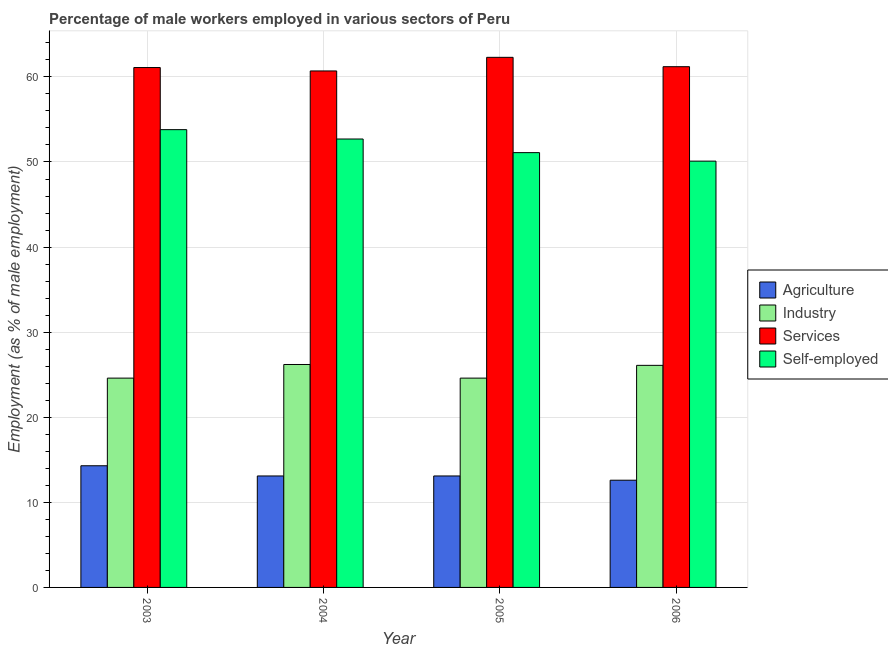How many groups of bars are there?
Provide a succinct answer. 4. Are the number of bars per tick equal to the number of legend labels?
Give a very brief answer. Yes. Are the number of bars on each tick of the X-axis equal?
Your answer should be very brief. Yes. What is the percentage of male workers in services in 2006?
Ensure brevity in your answer.  61.2. Across all years, what is the maximum percentage of male workers in industry?
Give a very brief answer. 26.2. Across all years, what is the minimum percentage of male workers in agriculture?
Your response must be concise. 12.6. In which year was the percentage of male workers in industry maximum?
Your answer should be very brief. 2004. In which year was the percentage of male workers in agriculture minimum?
Give a very brief answer. 2006. What is the total percentage of self employed male workers in the graph?
Your answer should be compact. 207.7. What is the average percentage of self employed male workers per year?
Offer a very short reply. 51.92. In the year 2005, what is the difference between the percentage of male workers in industry and percentage of male workers in agriculture?
Offer a terse response. 0. In how many years, is the percentage of male workers in industry greater than 14 %?
Provide a succinct answer. 4. What is the ratio of the percentage of male workers in services in 2003 to that in 2004?
Provide a succinct answer. 1.01. Is the percentage of male workers in agriculture in 2003 less than that in 2005?
Your response must be concise. No. What is the difference between the highest and the second highest percentage of male workers in industry?
Give a very brief answer. 0.1. What is the difference between the highest and the lowest percentage of male workers in industry?
Your answer should be compact. 1.6. Is the sum of the percentage of self employed male workers in 2005 and 2006 greater than the maximum percentage of male workers in services across all years?
Your response must be concise. Yes. What does the 3rd bar from the left in 2004 represents?
Provide a short and direct response. Services. What does the 4th bar from the right in 2006 represents?
Provide a succinct answer. Agriculture. Is it the case that in every year, the sum of the percentage of male workers in agriculture and percentage of male workers in industry is greater than the percentage of male workers in services?
Your response must be concise. No. Are all the bars in the graph horizontal?
Offer a very short reply. No. Are the values on the major ticks of Y-axis written in scientific E-notation?
Keep it short and to the point. No. Where does the legend appear in the graph?
Offer a very short reply. Center right. How are the legend labels stacked?
Give a very brief answer. Vertical. What is the title of the graph?
Keep it short and to the point. Percentage of male workers employed in various sectors of Peru. What is the label or title of the X-axis?
Your answer should be very brief. Year. What is the label or title of the Y-axis?
Your answer should be compact. Employment (as % of male employment). What is the Employment (as % of male employment) in Agriculture in 2003?
Give a very brief answer. 14.3. What is the Employment (as % of male employment) in Industry in 2003?
Keep it short and to the point. 24.6. What is the Employment (as % of male employment) of Services in 2003?
Ensure brevity in your answer.  61.1. What is the Employment (as % of male employment) in Self-employed in 2003?
Offer a terse response. 53.8. What is the Employment (as % of male employment) in Agriculture in 2004?
Give a very brief answer. 13.1. What is the Employment (as % of male employment) in Industry in 2004?
Keep it short and to the point. 26.2. What is the Employment (as % of male employment) of Services in 2004?
Offer a very short reply. 60.7. What is the Employment (as % of male employment) in Self-employed in 2004?
Provide a short and direct response. 52.7. What is the Employment (as % of male employment) in Agriculture in 2005?
Offer a terse response. 13.1. What is the Employment (as % of male employment) of Industry in 2005?
Give a very brief answer. 24.6. What is the Employment (as % of male employment) of Services in 2005?
Your response must be concise. 62.3. What is the Employment (as % of male employment) in Self-employed in 2005?
Provide a short and direct response. 51.1. What is the Employment (as % of male employment) of Agriculture in 2006?
Your answer should be very brief. 12.6. What is the Employment (as % of male employment) in Industry in 2006?
Offer a very short reply. 26.1. What is the Employment (as % of male employment) of Services in 2006?
Give a very brief answer. 61.2. What is the Employment (as % of male employment) in Self-employed in 2006?
Offer a terse response. 50.1. Across all years, what is the maximum Employment (as % of male employment) of Agriculture?
Offer a very short reply. 14.3. Across all years, what is the maximum Employment (as % of male employment) of Industry?
Offer a terse response. 26.2. Across all years, what is the maximum Employment (as % of male employment) of Services?
Your answer should be very brief. 62.3. Across all years, what is the maximum Employment (as % of male employment) of Self-employed?
Keep it short and to the point. 53.8. Across all years, what is the minimum Employment (as % of male employment) of Agriculture?
Make the answer very short. 12.6. Across all years, what is the minimum Employment (as % of male employment) of Industry?
Make the answer very short. 24.6. Across all years, what is the minimum Employment (as % of male employment) of Services?
Your answer should be very brief. 60.7. Across all years, what is the minimum Employment (as % of male employment) of Self-employed?
Keep it short and to the point. 50.1. What is the total Employment (as % of male employment) of Agriculture in the graph?
Provide a succinct answer. 53.1. What is the total Employment (as % of male employment) of Industry in the graph?
Offer a very short reply. 101.5. What is the total Employment (as % of male employment) of Services in the graph?
Your answer should be compact. 245.3. What is the total Employment (as % of male employment) of Self-employed in the graph?
Offer a terse response. 207.7. What is the difference between the Employment (as % of male employment) of Agriculture in 2003 and that in 2004?
Give a very brief answer. 1.2. What is the difference between the Employment (as % of male employment) in Industry in 2003 and that in 2004?
Provide a short and direct response. -1.6. What is the difference between the Employment (as % of male employment) of Industry in 2003 and that in 2005?
Ensure brevity in your answer.  0. What is the difference between the Employment (as % of male employment) in Self-employed in 2003 and that in 2005?
Provide a short and direct response. 2.7. What is the difference between the Employment (as % of male employment) of Industry in 2004 and that in 2005?
Ensure brevity in your answer.  1.6. What is the difference between the Employment (as % of male employment) in Services in 2004 and that in 2005?
Offer a terse response. -1.6. What is the difference between the Employment (as % of male employment) in Agriculture in 2004 and that in 2006?
Provide a succinct answer. 0.5. What is the difference between the Employment (as % of male employment) of Industry in 2004 and that in 2006?
Your answer should be very brief. 0.1. What is the difference between the Employment (as % of male employment) of Services in 2004 and that in 2006?
Offer a terse response. -0.5. What is the difference between the Employment (as % of male employment) in Self-employed in 2004 and that in 2006?
Give a very brief answer. 2.6. What is the difference between the Employment (as % of male employment) of Agriculture in 2005 and that in 2006?
Make the answer very short. 0.5. What is the difference between the Employment (as % of male employment) of Agriculture in 2003 and the Employment (as % of male employment) of Industry in 2004?
Offer a very short reply. -11.9. What is the difference between the Employment (as % of male employment) in Agriculture in 2003 and the Employment (as % of male employment) in Services in 2004?
Provide a succinct answer. -46.4. What is the difference between the Employment (as % of male employment) in Agriculture in 2003 and the Employment (as % of male employment) in Self-employed in 2004?
Offer a terse response. -38.4. What is the difference between the Employment (as % of male employment) in Industry in 2003 and the Employment (as % of male employment) in Services in 2004?
Offer a very short reply. -36.1. What is the difference between the Employment (as % of male employment) in Industry in 2003 and the Employment (as % of male employment) in Self-employed in 2004?
Offer a very short reply. -28.1. What is the difference between the Employment (as % of male employment) of Services in 2003 and the Employment (as % of male employment) of Self-employed in 2004?
Ensure brevity in your answer.  8.4. What is the difference between the Employment (as % of male employment) in Agriculture in 2003 and the Employment (as % of male employment) in Services in 2005?
Your answer should be very brief. -48. What is the difference between the Employment (as % of male employment) of Agriculture in 2003 and the Employment (as % of male employment) of Self-employed in 2005?
Give a very brief answer. -36.8. What is the difference between the Employment (as % of male employment) of Industry in 2003 and the Employment (as % of male employment) of Services in 2005?
Offer a terse response. -37.7. What is the difference between the Employment (as % of male employment) in Industry in 2003 and the Employment (as % of male employment) in Self-employed in 2005?
Ensure brevity in your answer.  -26.5. What is the difference between the Employment (as % of male employment) of Services in 2003 and the Employment (as % of male employment) of Self-employed in 2005?
Offer a very short reply. 10. What is the difference between the Employment (as % of male employment) in Agriculture in 2003 and the Employment (as % of male employment) in Industry in 2006?
Your answer should be very brief. -11.8. What is the difference between the Employment (as % of male employment) in Agriculture in 2003 and the Employment (as % of male employment) in Services in 2006?
Ensure brevity in your answer.  -46.9. What is the difference between the Employment (as % of male employment) of Agriculture in 2003 and the Employment (as % of male employment) of Self-employed in 2006?
Offer a terse response. -35.8. What is the difference between the Employment (as % of male employment) in Industry in 2003 and the Employment (as % of male employment) in Services in 2006?
Your response must be concise. -36.6. What is the difference between the Employment (as % of male employment) in Industry in 2003 and the Employment (as % of male employment) in Self-employed in 2006?
Your answer should be very brief. -25.5. What is the difference between the Employment (as % of male employment) of Services in 2003 and the Employment (as % of male employment) of Self-employed in 2006?
Provide a short and direct response. 11. What is the difference between the Employment (as % of male employment) in Agriculture in 2004 and the Employment (as % of male employment) in Services in 2005?
Offer a very short reply. -49.2. What is the difference between the Employment (as % of male employment) of Agriculture in 2004 and the Employment (as % of male employment) of Self-employed in 2005?
Give a very brief answer. -38. What is the difference between the Employment (as % of male employment) in Industry in 2004 and the Employment (as % of male employment) in Services in 2005?
Offer a terse response. -36.1. What is the difference between the Employment (as % of male employment) of Industry in 2004 and the Employment (as % of male employment) of Self-employed in 2005?
Provide a succinct answer. -24.9. What is the difference between the Employment (as % of male employment) of Agriculture in 2004 and the Employment (as % of male employment) of Services in 2006?
Make the answer very short. -48.1. What is the difference between the Employment (as % of male employment) of Agriculture in 2004 and the Employment (as % of male employment) of Self-employed in 2006?
Keep it short and to the point. -37. What is the difference between the Employment (as % of male employment) in Industry in 2004 and the Employment (as % of male employment) in Services in 2006?
Offer a terse response. -35. What is the difference between the Employment (as % of male employment) in Industry in 2004 and the Employment (as % of male employment) in Self-employed in 2006?
Ensure brevity in your answer.  -23.9. What is the difference between the Employment (as % of male employment) of Services in 2004 and the Employment (as % of male employment) of Self-employed in 2006?
Your answer should be compact. 10.6. What is the difference between the Employment (as % of male employment) of Agriculture in 2005 and the Employment (as % of male employment) of Industry in 2006?
Offer a terse response. -13. What is the difference between the Employment (as % of male employment) of Agriculture in 2005 and the Employment (as % of male employment) of Services in 2006?
Keep it short and to the point. -48.1. What is the difference between the Employment (as % of male employment) in Agriculture in 2005 and the Employment (as % of male employment) in Self-employed in 2006?
Offer a terse response. -37. What is the difference between the Employment (as % of male employment) of Industry in 2005 and the Employment (as % of male employment) of Services in 2006?
Provide a short and direct response. -36.6. What is the difference between the Employment (as % of male employment) in Industry in 2005 and the Employment (as % of male employment) in Self-employed in 2006?
Make the answer very short. -25.5. What is the difference between the Employment (as % of male employment) of Services in 2005 and the Employment (as % of male employment) of Self-employed in 2006?
Make the answer very short. 12.2. What is the average Employment (as % of male employment) in Agriculture per year?
Offer a very short reply. 13.28. What is the average Employment (as % of male employment) in Industry per year?
Provide a short and direct response. 25.38. What is the average Employment (as % of male employment) of Services per year?
Keep it short and to the point. 61.33. What is the average Employment (as % of male employment) of Self-employed per year?
Keep it short and to the point. 51.92. In the year 2003, what is the difference between the Employment (as % of male employment) in Agriculture and Employment (as % of male employment) in Services?
Your response must be concise. -46.8. In the year 2003, what is the difference between the Employment (as % of male employment) in Agriculture and Employment (as % of male employment) in Self-employed?
Your answer should be very brief. -39.5. In the year 2003, what is the difference between the Employment (as % of male employment) of Industry and Employment (as % of male employment) of Services?
Provide a succinct answer. -36.5. In the year 2003, what is the difference between the Employment (as % of male employment) in Industry and Employment (as % of male employment) in Self-employed?
Your response must be concise. -29.2. In the year 2003, what is the difference between the Employment (as % of male employment) in Services and Employment (as % of male employment) in Self-employed?
Offer a terse response. 7.3. In the year 2004, what is the difference between the Employment (as % of male employment) in Agriculture and Employment (as % of male employment) in Services?
Provide a succinct answer. -47.6. In the year 2004, what is the difference between the Employment (as % of male employment) in Agriculture and Employment (as % of male employment) in Self-employed?
Your answer should be compact. -39.6. In the year 2004, what is the difference between the Employment (as % of male employment) of Industry and Employment (as % of male employment) of Services?
Keep it short and to the point. -34.5. In the year 2004, what is the difference between the Employment (as % of male employment) in Industry and Employment (as % of male employment) in Self-employed?
Give a very brief answer. -26.5. In the year 2005, what is the difference between the Employment (as % of male employment) in Agriculture and Employment (as % of male employment) in Industry?
Your answer should be compact. -11.5. In the year 2005, what is the difference between the Employment (as % of male employment) of Agriculture and Employment (as % of male employment) of Services?
Give a very brief answer. -49.2. In the year 2005, what is the difference between the Employment (as % of male employment) of Agriculture and Employment (as % of male employment) of Self-employed?
Make the answer very short. -38. In the year 2005, what is the difference between the Employment (as % of male employment) in Industry and Employment (as % of male employment) in Services?
Give a very brief answer. -37.7. In the year 2005, what is the difference between the Employment (as % of male employment) of Industry and Employment (as % of male employment) of Self-employed?
Keep it short and to the point. -26.5. In the year 2005, what is the difference between the Employment (as % of male employment) of Services and Employment (as % of male employment) of Self-employed?
Keep it short and to the point. 11.2. In the year 2006, what is the difference between the Employment (as % of male employment) of Agriculture and Employment (as % of male employment) of Services?
Keep it short and to the point. -48.6. In the year 2006, what is the difference between the Employment (as % of male employment) of Agriculture and Employment (as % of male employment) of Self-employed?
Provide a short and direct response. -37.5. In the year 2006, what is the difference between the Employment (as % of male employment) in Industry and Employment (as % of male employment) in Services?
Your answer should be compact. -35.1. In the year 2006, what is the difference between the Employment (as % of male employment) in Services and Employment (as % of male employment) in Self-employed?
Offer a very short reply. 11.1. What is the ratio of the Employment (as % of male employment) in Agriculture in 2003 to that in 2004?
Your response must be concise. 1.09. What is the ratio of the Employment (as % of male employment) of Industry in 2003 to that in 2004?
Keep it short and to the point. 0.94. What is the ratio of the Employment (as % of male employment) in Services in 2003 to that in 2004?
Offer a very short reply. 1.01. What is the ratio of the Employment (as % of male employment) of Self-employed in 2003 to that in 2004?
Ensure brevity in your answer.  1.02. What is the ratio of the Employment (as % of male employment) in Agriculture in 2003 to that in 2005?
Give a very brief answer. 1.09. What is the ratio of the Employment (as % of male employment) in Services in 2003 to that in 2005?
Your response must be concise. 0.98. What is the ratio of the Employment (as % of male employment) of Self-employed in 2003 to that in 2005?
Your response must be concise. 1.05. What is the ratio of the Employment (as % of male employment) in Agriculture in 2003 to that in 2006?
Your answer should be very brief. 1.13. What is the ratio of the Employment (as % of male employment) of Industry in 2003 to that in 2006?
Ensure brevity in your answer.  0.94. What is the ratio of the Employment (as % of male employment) in Self-employed in 2003 to that in 2006?
Provide a succinct answer. 1.07. What is the ratio of the Employment (as % of male employment) in Agriculture in 2004 to that in 2005?
Give a very brief answer. 1. What is the ratio of the Employment (as % of male employment) in Industry in 2004 to that in 2005?
Provide a succinct answer. 1.06. What is the ratio of the Employment (as % of male employment) in Services in 2004 to that in 2005?
Ensure brevity in your answer.  0.97. What is the ratio of the Employment (as % of male employment) in Self-employed in 2004 to that in 2005?
Your response must be concise. 1.03. What is the ratio of the Employment (as % of male employment) in Agriculture in 2004 to that in 2006?
Provide a succinct answer. 1.04. What is the ratio of the Employment (as % of male employment) of Services in 2004 to that in 2006?
Your answer should be compact. 0.99. What is the ratio of the Employment (as % of male employment) in Self-employed in 2004 to that in 2006?
Keep it short and to the point. 1.05. What is the ratio of the Employment (as % of male employment) of Agriculture in 2005 to that in 2006?
Provide a short and direct response. 1.04. What is the ratio of the Employment (as % of male employment) of Industry in 2005 to that in 2006?
Your response must be concise. 0.94. What is the ratio of the Employment (as % of male employment) in Self-employed in 2005 to that in 2006?
Your response must be concise. 1.02. What is the difference between the highest and the second highest Employment (as % of male employment) in Self-employed?
Offer a very short reply. 1.1. What is the difference between the highest and the lowest Employment (as % of male employment) in Industry?
Offer a terse response. 1.6. What is the difference between the highest and the lowest Employment (as % of male employment) in Services?
Your response must be concise. 1.6. 